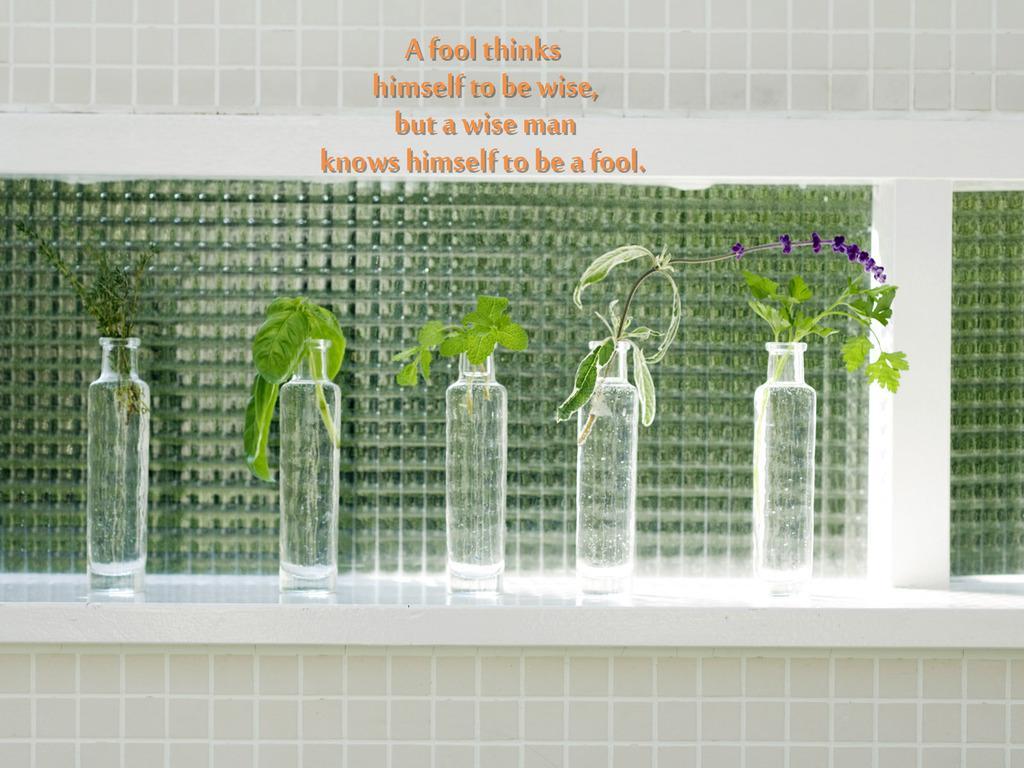Please provide a concise description of this image. In this picture there are five bottles. There are five plants in these bottles. These are placed on the table. Wall is green in color at the background. 